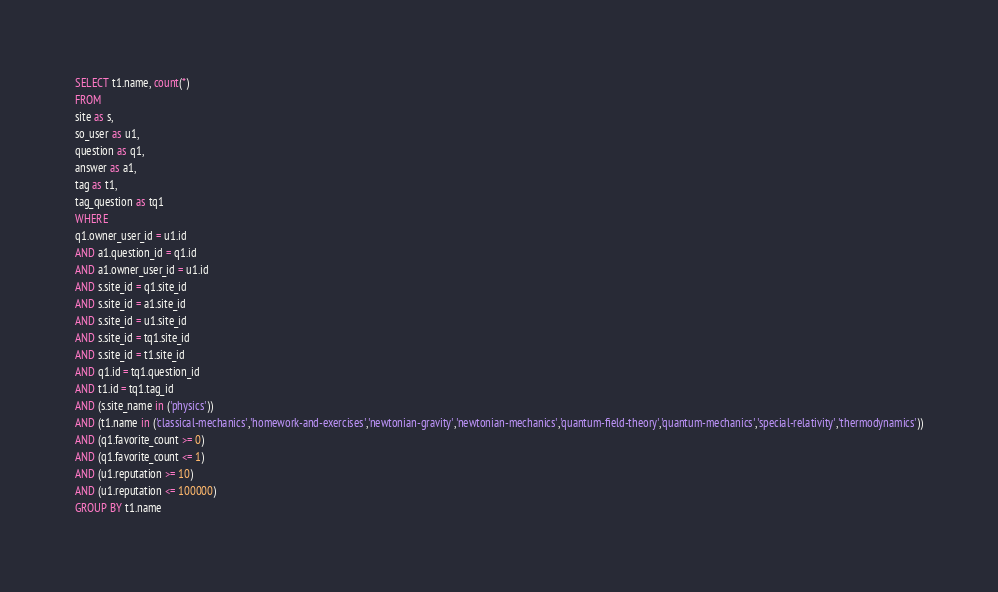Convert code to text. <code><loc_0><loc_0><loc_500><loc_500><_SQL_>SELECT t1.name, count(*)
FROM
site as s,
so_user as u1,
question as q1,
answer as a1,
tag as t1,
tag_question as tq1
WHERE
q1.owner_user_id = u1.id
AND a1.question_id = q1.id
AND a1.owner_user_id = u1.id
AND s.site_id = q1.site_id
AND s.site_id = a1.site_id
AND s.site_id = u1.site_id
AND s.site_id = tq1.site_id
AND s.site_id = t1.site_id
AND q1.id = tq1.question_id
AND t1.id = tq1.tag_id
AND (s.site_name in ('physics'))
AND (t1.name in ('classical-mechanics','homework-and-exercises','newtonian-gravity','newtonian-mechanics','quantum-field-theory','quantum-mechanics','special-relativity','thermodynamics'))
AND (q1.favorite_count >= 0)
AND (q1.favorite_count <= 1)
AND (u1.reputation >= 10)
AND (u1.reputation <= 100000)
GROUP BY t1.name</code> 